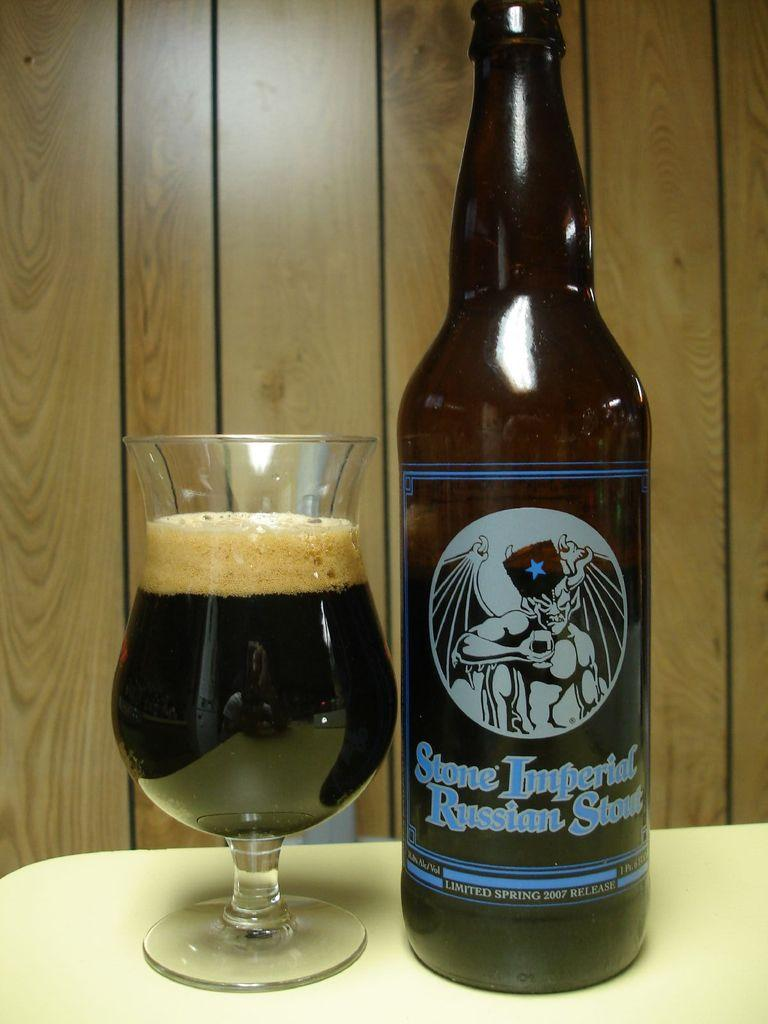<image>
Provide a brief description of the given image. A glass is poured with Stone Imperial Russian Stout. 